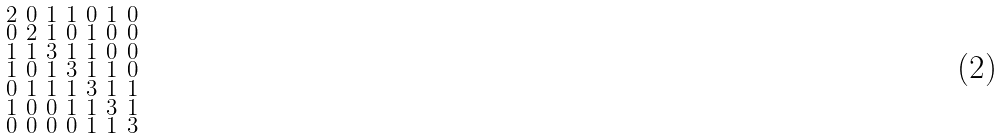Convert formula to latex. <formula><loc_0><loc_0><loc_500><loc_500>\begin{smallmatrix} 2 & 0 & 1 & 1 & 0 & 1 & 0 \\ 0 & 2 & 1 & 0 & 1 & 0 & 0 \\ 1 & 1 & 3 & 1 & 1 & 0 & 0 \\ 1 & 0 & 1 & 3 & 1 & 1 & 0 \\ 0 & 1 & 1 & 1 & 3 & 1 & 1 \\ 1 & 0 & 0 & 1 & 1 & 3 & 1 \\ 0 & 0 & 0 & 0 & 1 & 1 & 3 \end{smallmatrix}</formula> 